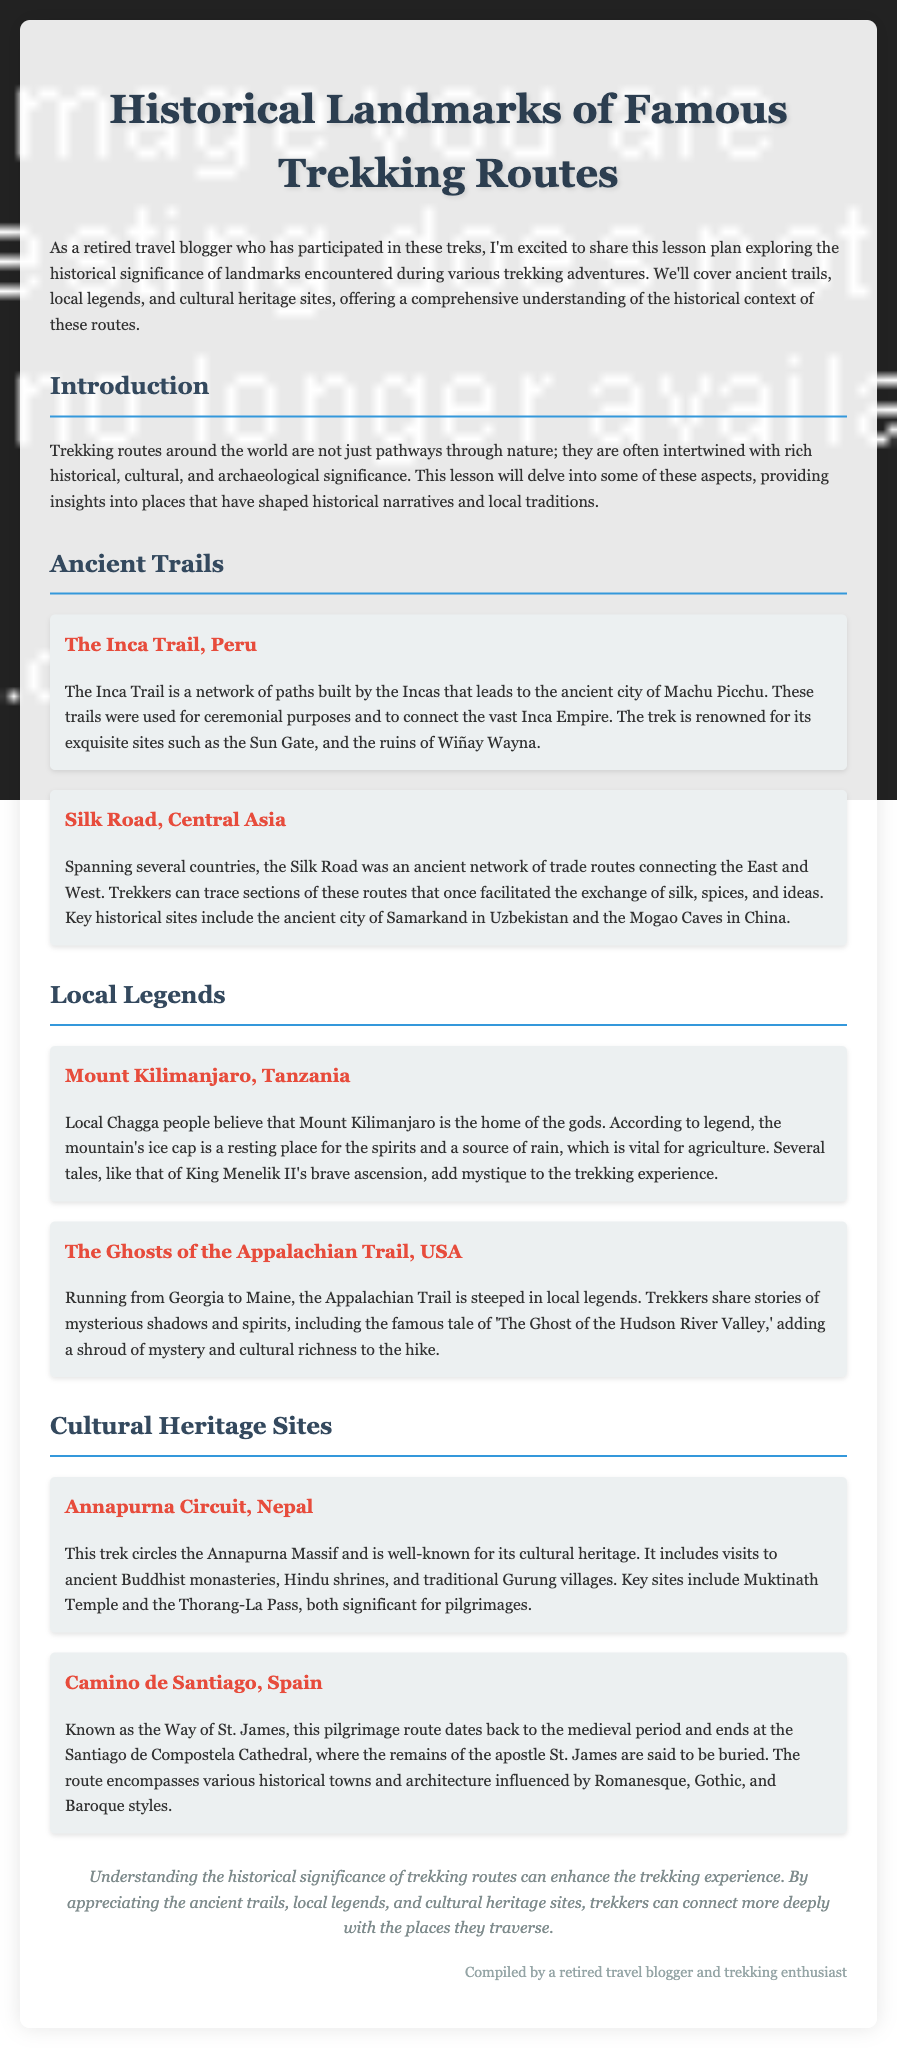What is the title of the document? The title of the document is the main header presented at the top, indicating the lesson plan's focus.
Answer: Historical Landmarks of Famous Trekking Routes What ancient trail is associated with Machu Picchu? The document specifies a famous trekking route that leads to the ancient city of Machu Picchu.
Answer: Inca Trail Which country features the Silk Road? The document mentions the Silk Road as an ancient network of trade routes spanning several countries.
Answer: Central Asia What do the Chagga people believe about Mount Kilimanjaro? The belief discussed in the document highlights the significance of Mount Kilimanjaro in local legend.
Answer: Home of the gods What is the primary cultural significance of the Annapurna Circuit? The document describes the cultural heritage aspects of a specific trek.
Answer: Ancient Buddhist monasteries What historical figure is associated with the legends of Mount Kilimanjaro? The document references a particular historical figure related to the local legends of Mount Kilimanjaro.
Answer: King Menelik II How is the Appalachian Trail described in terms of local lore? The document elaborates on the local legends surrounding a specific trekking route in the USA.
Answer: Steeped in local legends What year could the Camino de Santiago be traced back to? The document indicates the medieval period as the beginning of this pilgrimage route.
Answer: Medieval period 